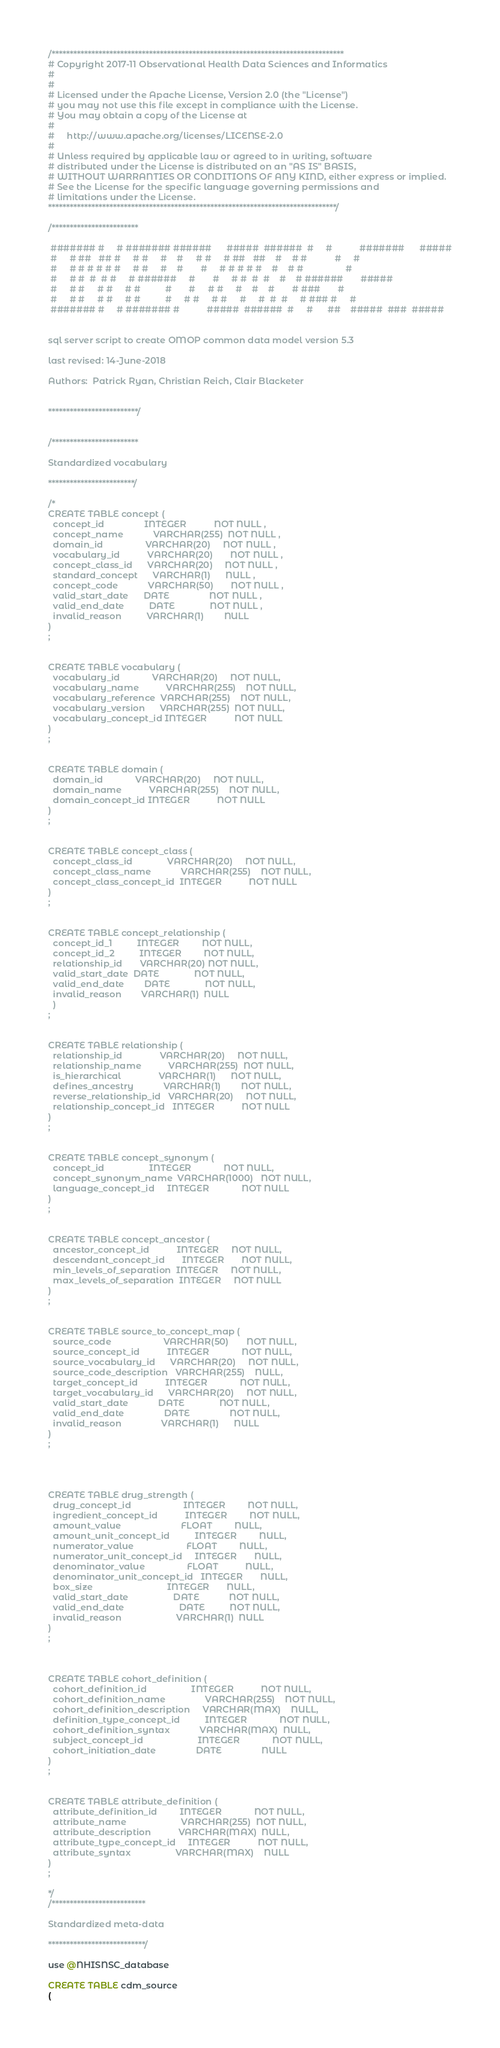Convert code to text. <code><loc_0><loc_0><loc_500><loc_500><_SQL_>/*********************************************************************************
# Copyright 2017-11 Observational Health Data Sciences and Informatics
#
#
# Licensed under the Apache License, Version 2.0 (the "License")
# you may not use this file except in compliance with the License.
# You may obtain a copy of the License at
#
#     http://www.apache.org/licenses/LICENSE-2.0
#
# Unless required by applicable law or agreed to in writing, software
# distributed under the License is distributed on an "AS IS" BASIS,
# WITHOUT WARRANTIES OR CONDITIONS OF ANY KIND, either express or implied.
# See the License for the specific language governing permissions and
# limitations under the License.
********************************************************************************/

/************************

 ####### #     # ####### ######      #####  ######  #     #           #######      #####
 #     # ##   ## #     # #     #    #     # #     # ##   ##    #    # #           #     #
 #     # # # # # #     # #     #    #       #     # # # # #    #    # #                 #
 #     # #  #  # #     # ######     #       #     # #  #  #    #    # ######       #####
 #     # #     # #     # #          #       #     # #     #    #    #       # ###       #
 #     # #     # #     # #          #     # #     # #     #     #  #  #     # ### #     #
 ####### #     # ####### #           #####  ######  #     #      ##    #####  ###  #####


sql server script to create OMOP common data model version 5.3

last revised: 14-June-2018

Authors:  Patrick Ryan, Christian Reich, Clair Blacketer


*************************/


/************************

Standardized vocabulary

************************/

/*
CREATE TABLE concept (
  concept_id			    INTEGER			  NOT NULL ,
  concept_name			  VARCHAR(255)	NOT NULL ,
  domain_id				    VARCHAR(20)		NOT NULL ,
  vocabulary_id			  VARCHAR(20)		NOT NULL ,
  concept_class_id		VARCHAR(20)		NOT NULL ,
  standard_concept		VARCHAR(1)		NULL ,
  concept_code			  VARCHAR(50)		NOT NULL ,
  valid_start_date		DATE			    NOT NULL ,
  valid_end_date		  DATE			    NOT NULL ,
  invalid_reason		  VARCHAR(1)		NULL
)
;


CREATE TABLE vocabulary (
  vocabulary_id			    VARCHAR(20)		NOT NULL,
  vocabulary_name		    VARCHAR(255)	NOT NULL,
  vocabulary_reference	VARCHAR(255)	NOT NULL,
  vocabulary_version	  VARCHAR(255)	NOT NULL,
  vocabulary_concept_id	INTEGER			  NOT NULL
)
;


CREATE TABLE domain (
  domain_id			    VARCHAR(20)		NOT NULL,
  domain_name		    VARCHAR(255)	NOT NULL,
  domain_concept_id	INTEGER			  NOT NULL
)
;


CREATE TABLE concept_class (
  concept_class_id			    VARCHAR(20)		NOT NULL,
  concept_class_name		    VARCHAR(255)	NOT NULL,
  concept_class_concept_id	INTEGER			  NOT NULL
)
;


CREATE TABLE concept_relationship (
  concept_id_1			INTEGER			NOT NULL,
  concept_id_2			INTEGER			NOT NULL,
  relationship_id		VARCHAR(20)	NOT NULL,
  valid_start_date	DATE			  NOT NULL,
  valid_end_date		DATE			  NOT NULL,
  invalid_reason		VARCHAR(1)	NULL
  )
;


CREATE TABLE relationship (
  relationship_id			    VARCHAR(20)		NOT NULL,
  relationship_name			  VARCHAR(255)	NOT NULL,
  is_hierarchical			    VARCHAR(1)		NOT NULL,
  defines_ancestry			  VARCHAR(1)		NOT NULL,
  reverse_relationship_id	VARCHAR(20)		NOT NULL,
  relationship_concept_id	INTEGER			  NOT NULL
)
;


CREATE TABLE concept_synonym (
  concept_id			      INTEGER			  NOT NULL,
  concept_synonym_name	VARCHAR(1000)	NOT NULL,
  language_concept_id	  INTEGER			  NOT NULL
)
;


CREATE TABLE concept_ancestor (
  ancestor_concept_id		    INTEGER		NOT NULL,
  descendant_concept_id		  INTEGER		NOT NULL,
  min_levels_of_separation	INTEGER		NOT NULL,
  max_levels_of_separation	INTEGER		NOT NULL
)
;


CREATE TABLE source_to_concept_map (
  source_code				      VARCHAR(50)		NOT NULL,
  source_concept_id			  INTEGER			  NOT NULL,
  source_vocabulary_id		VARCHAR(20)		NOT NULL,
  source_code_description	VARCHAR(255)	NULL,
  target_concept_id			  INTEGER			  NOT NULL,
  target_vocabulary_id		VARCHAR(20)		NOT NULL,
  valid_start_date			  DATE			    NOT NULL,
  valid_end_date			    DATE			    NOT NULL,
  invalid_reason			    VARCHAR(1)		NULL
)
;




CREATE TABLE drug_strength (
  drug_concept_id				      INTEGER		  NOT NULL,
  ingredient_concept_id			  INTEGER		  NOT NULL,
  amount_value					      FLOAT		    NULL,
  amount_unit_concept_id		  INTEGER		  NULL,
  numerator_value				      FLOAT		    NULL,
  numerator_unit_concept_id		INTEGER		  NULL,
  denominator_value				    FLOAT		    NULL,
  denominator_unit_concept_id	INTEGER		  NULL,
  box_size						        INTEGER		  NULL,
  valid_start_date				    DATE		    NOT NULL,
  valid_end_date				      DATE		    NOT NULL,
  invalid_reason				      VARCHAR(1)  NULL
)
;



CREATE TABLE cohort_definition (
  cohort_definition_id				    INTEGER			  NOT NULL,
  cohort_definition_name			    VARCHAR(255)	NOT NULL,
  cohort_definition_description		VARCHAR(MAX)	NULL,
  definition_type_concept_id		  INTEGER			  NOT NULL,
  cohort_definition_syntax			  VARCHAR(MAX)	NULL,
  subject_concept_id				      INTEGER			  NOT NULL,
  cohort_initiation_date			    DATE			    NULL
)
;


CREATE TABLE attribute_definition (
  attribute_definition_id		  INTEGER			  NOT NULL,
  attribute_name				      VARCHAR(255)	NOT NULL,
  attribute_description			  VARCHAR(MAX)	NULL,
  attribute_type_concept_id		INTEGER			  NOT NULL,
  attribute_syntax				    VARCHAR(MAX)	NULL
)
;

*/
/**************************

Standardized meta-data

***************************/

use @NHISNSC_database

CREATE TABLE cdm_source
(</code> 